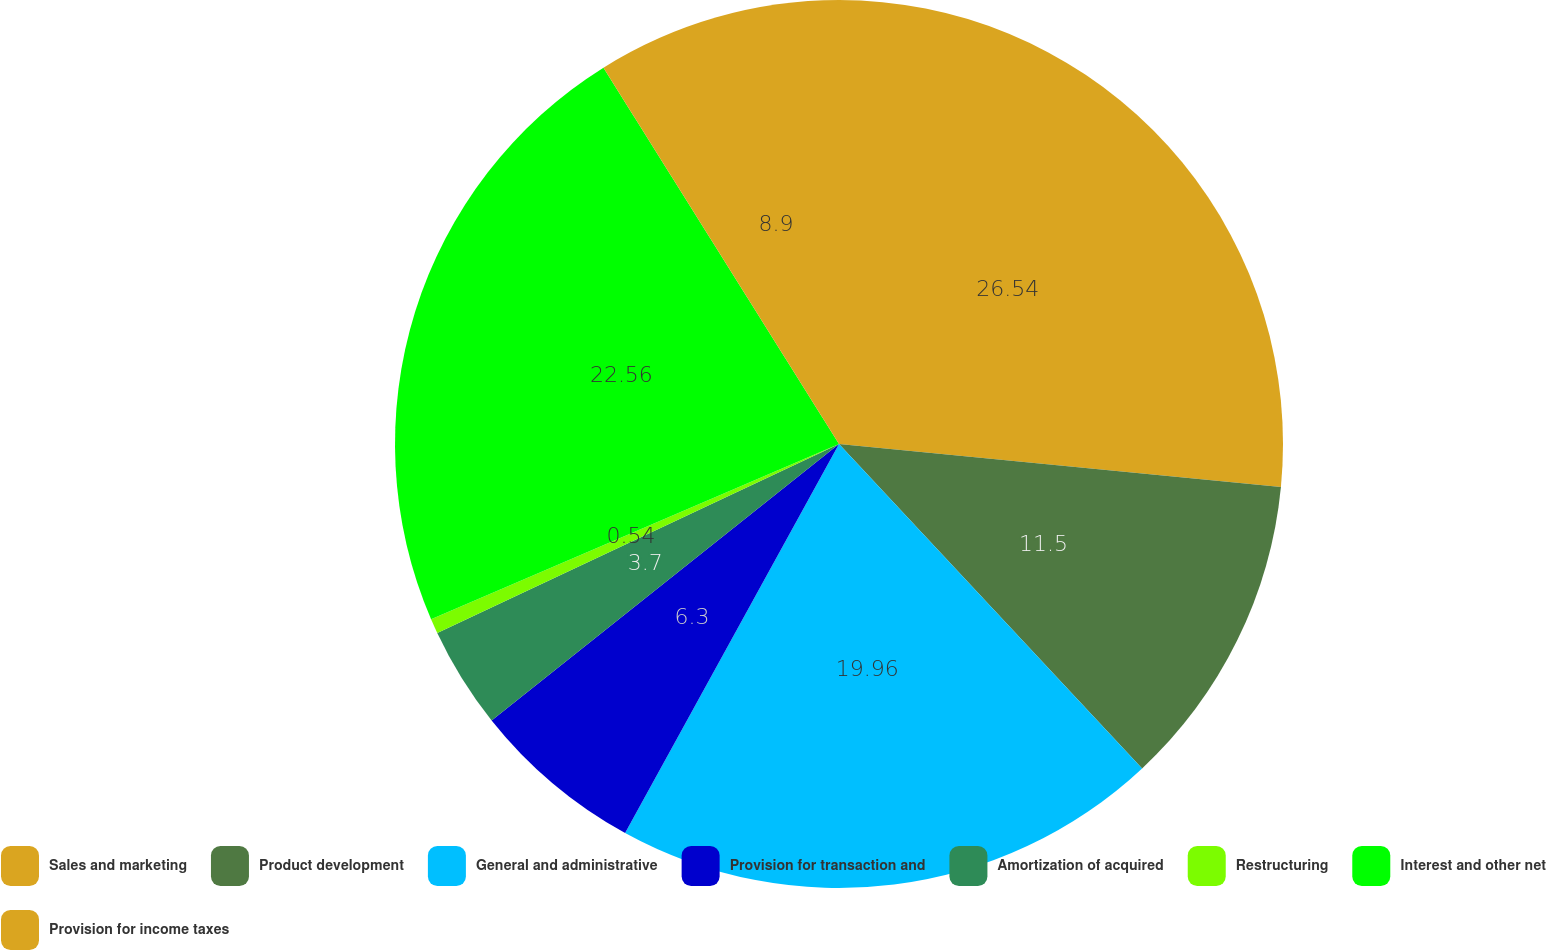<chart> <loc_0><loc_0><loc_500><loc_500><pie_chart><fcel>Sales and marketing<fcel>Product development<fcel>General and administrative<fcel>Provision for transaction and<fcel>Amortization of acquired<fcel>Restructuring<fcel>Interest and other net<fcel>Provision for income taxes<nl><fcel>26.54%<fcel>11.5%<fcel>19.96%<fcel>6.3%<fcel>3.7%<fcel>0.54%<fcel>22.56%<fcel>8.9%<nl></chart> 